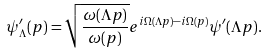<formula> <loc_0><loc_0><loc_500><loc_500>\psi ^ { \prime } _ { \Lambda } ( { p } ) = \sqrt { \frac { \omega ( { \Lambda p } ) } { \omega ( { p } ) } } e ^ { i \Omega ( { \Lambda p } ) - i \Omega ( { p } ) } \psi ^ { \prime } ( { \Lambda p } ) .</formula> 